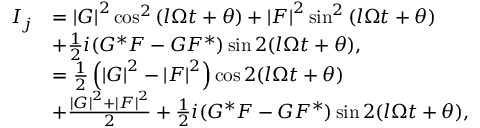<formula> <loc_0><loc_0><loc_500><loc_500>\begin{array} { r l } { I _ { j } } & { = \left | G \right | ^ { 2 } \cos ^ { 2 } \left ( l \Omega t + \theta \right ) + \left | F \right | ^ { 2 } \sin ^ { 2 } \left ( l \Omega t + \theta \right ) } \\ & { + \frac { 1 } { 2 } i ( G ^ { \ast } F - G F ^ { \ast } ) \sin 2 ( l \Omega t + \theta ) , } \\ & { = \frac { 1 } { 2 } \left ( \left | G \right | ^ { 2 } - \left | F \right | ^ { 2 } \right ) \cos 2 ( l \Omega t + \theta ) } \\ & { + \frac { \left | G \right | ^ { 2 } + \left | F \right | ^ { 2 } } { 2 } + \frac { 1 } { 2 } i ( G ^ { \ast } F - G F ^ { \ast } ) \sin 2 ( l \Omega t + \theta ) , } \end{array}</formula> 